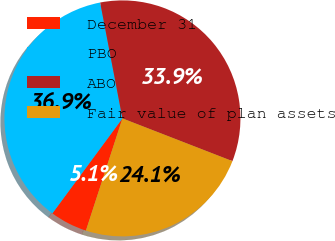Convert chart to OTSL. <chart><loc_0><loc_0><loc_500><loc_500><pie_chart><fcel>December 31<fcel>PBO<fcel>ABO<fcel>Fair value of plan assets<nl><fcel>5.11%<fcel>36.86%<fcel>33.92%<fcel>24.11%<nl></chart> 